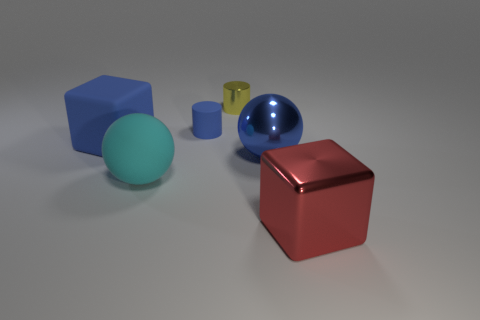Add 4 big brown spheres. How many objects exist? 10 Add 4 big matte objects. How many big matte objects exist? 6 Subtract 0 brown spheres. How many objects are left? 6 Subtract all tiny blue metal spheres. Subtract all metallic things. How many objects are left? 3 Add 3 blue rubber cylinders. How many blue rubber cylinders are left? 4 